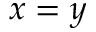Convert formula to latex. <formula><loc_0><loc_0><loc_500><loc_500>x = y</formula> 